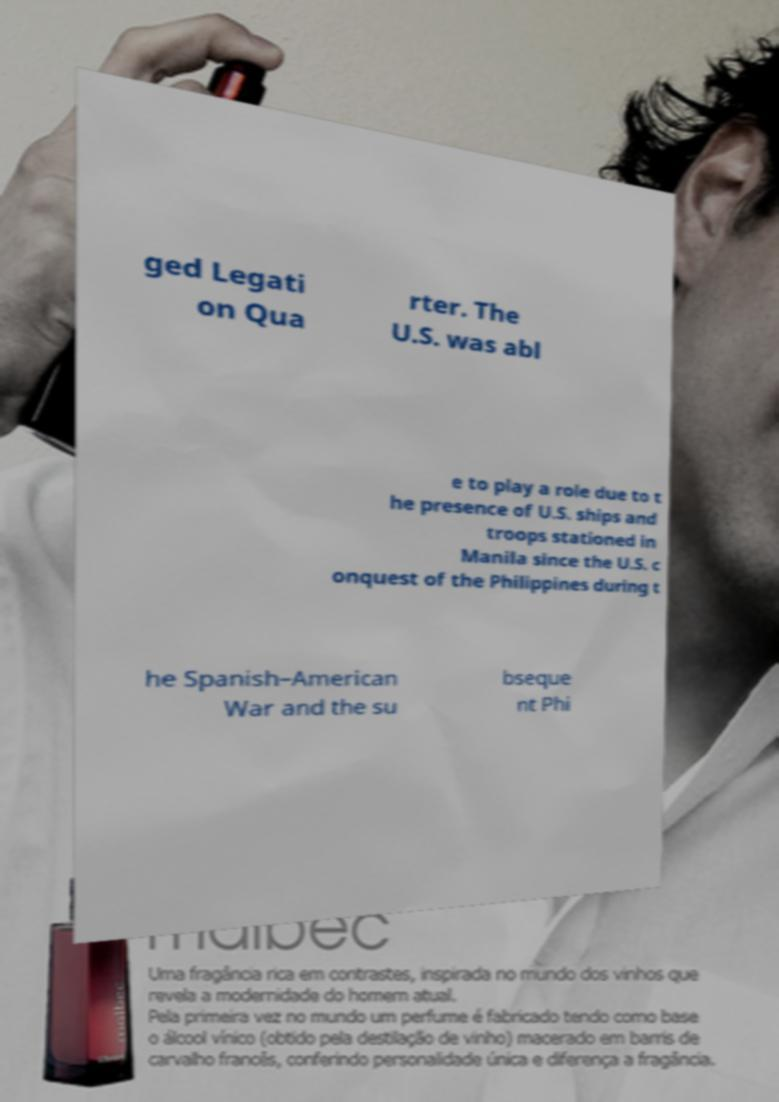Please read and relay the text visible in this image. What does it say? ged Legati on Qua rter. The U.S. was abl e to play a role due to t he presence of U.S. ships and troops stationed in Manila since the U.S. c onquest of the Philippines during t he Spanish–American War and the su bseque nt Phi 